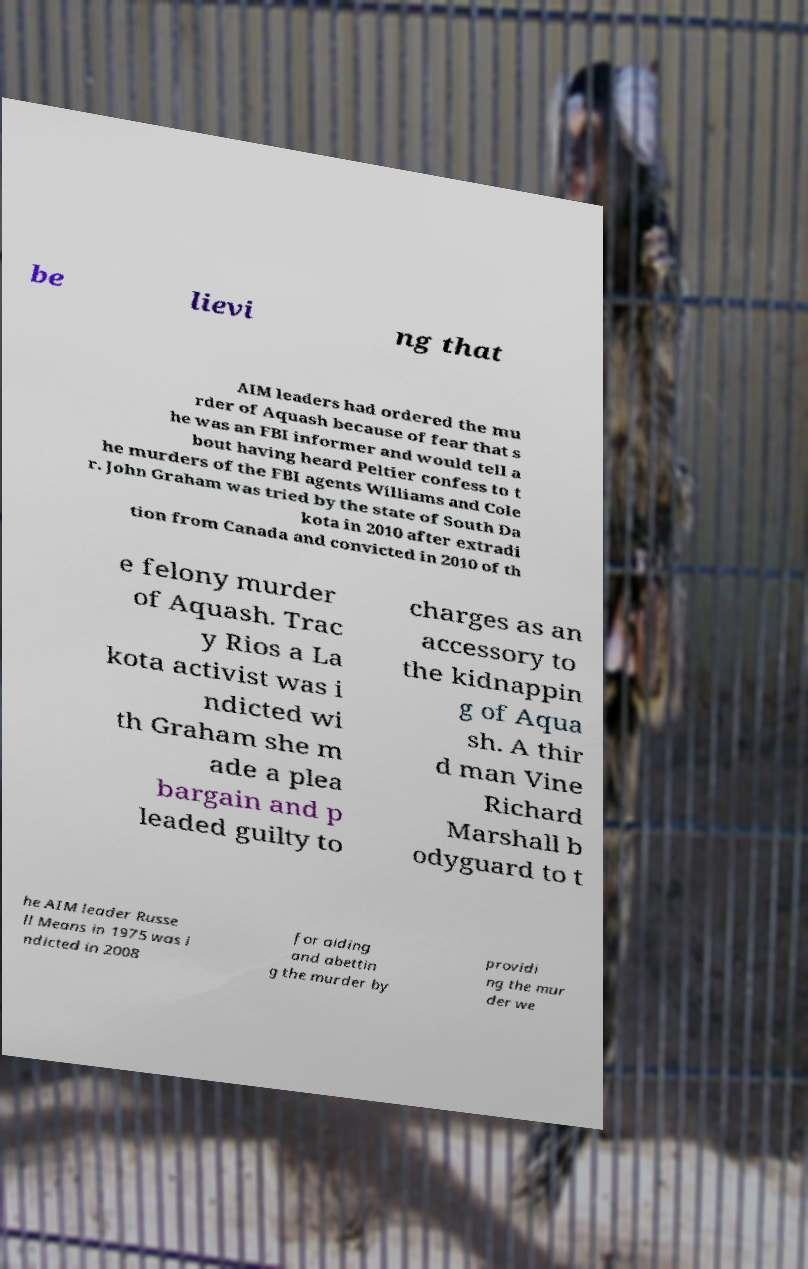For documentation purposes, I need the text within this image transcribed. Could you provide that? be lievi ng that AIM leaders had ordered the mu rder of Aquash because of fear that s he was an FBI informer and would tell a bout having heard Peltier confess to t he murders of the FBI agents Williams and Cole r. John Graham was tried by the state of South Da kota in 2010 after extradi tion from Canada and convicted in 2010 of th e felony murder of Aquash. Trac y Rios a La kota activist was i ndicted wi th Graham she m ade a plea bargain and p leaded guilty to charges as an accessory to the kidnappin g of Aqua sh. A thir d man Vine Richard Marshall b odyguard to t he AIM leader Russe ll Means in 1975 was i ndicted in 2008 for aiding and abettin g the murder by providi ng the mur der we 